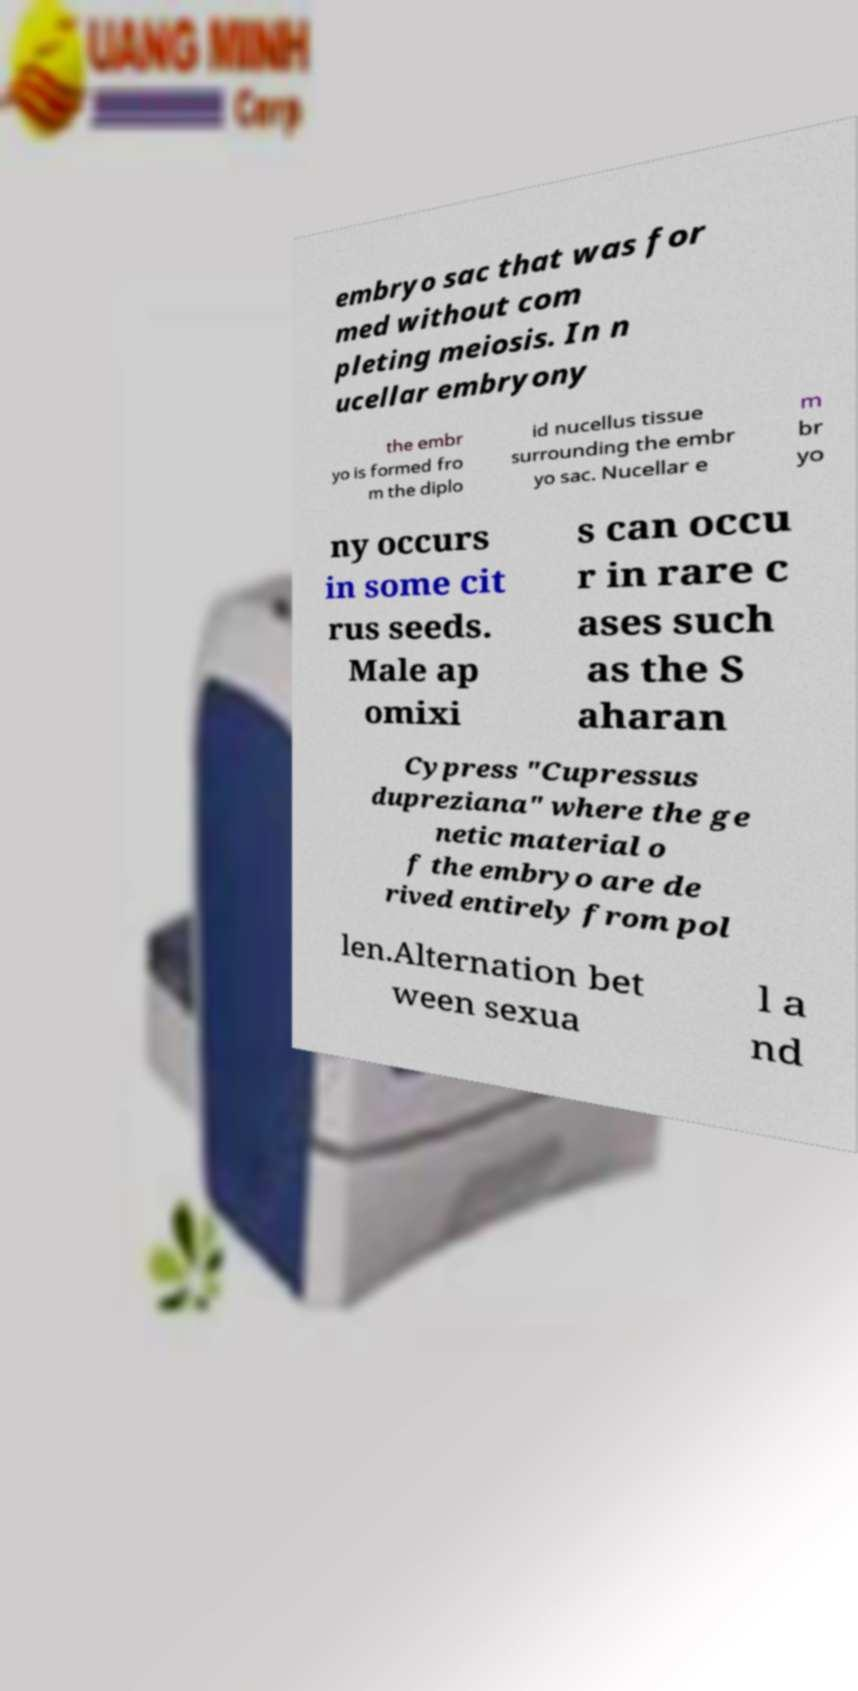Please identify and transcribe the text found in this image. embryo sac that was for med without com pleting meiosis. In n ucellar embryony the embr yo is formed fro m the diplo id nucellus tissue surrounding the embr yo sac. Nucellar e m br yo ny occurs in some cit rus seeds. Male ap omixi s can occu r in rare c ases such as the S aharan Cypress "Cupressus dupreziana" where the ge netic material o f the embryo are de rived entirely from pol len.Alternation bet ween sexua l a nd 